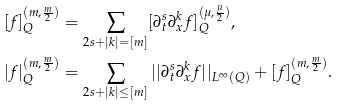Convert formula to latex. <formula><loc_0><loc_0><loc_500><loc_500>& [ f ] _ { Q } ^ { ( m , \frac { m } { 2 } ) } = \sum _ { 2 s + | k | = [ m ] } [ \partial _ { t } ^ { s } \partial _ { x } ^ { k } f ] ^ { ( \mu , \frac { \mu } { 2 } ) } _ { Q } , \\ & | f | _ { Q } ^ { ( m , \frac { m } { 2 } ) } = \sum _ { 2 s + | k | \leq [ m ] } | | \partial _ { t } ^ { s } \partial _ { x } ^ { k } f | | _ { L ^ { \infty } ( Q ) } + [ f ] _ { Q } ^ { ( m , \frac { m } { 2 } ) } .</formula> 